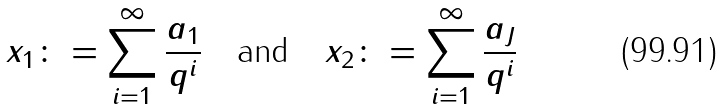Convert formula to latex. <formula><loc_0><loc_0><loc_500><loc_500>x _ { 1 } \colon = \sum _ { i = 1 } ^ { \infty } \frac { a _ { 1 } } { q ^ { i } } \quad \text {and} \quad x _ { 2 } \colon = \sum _ { i = 1 } ^ { \infty } \frac { a _ { J } } { q ^ { i } }</formula> 